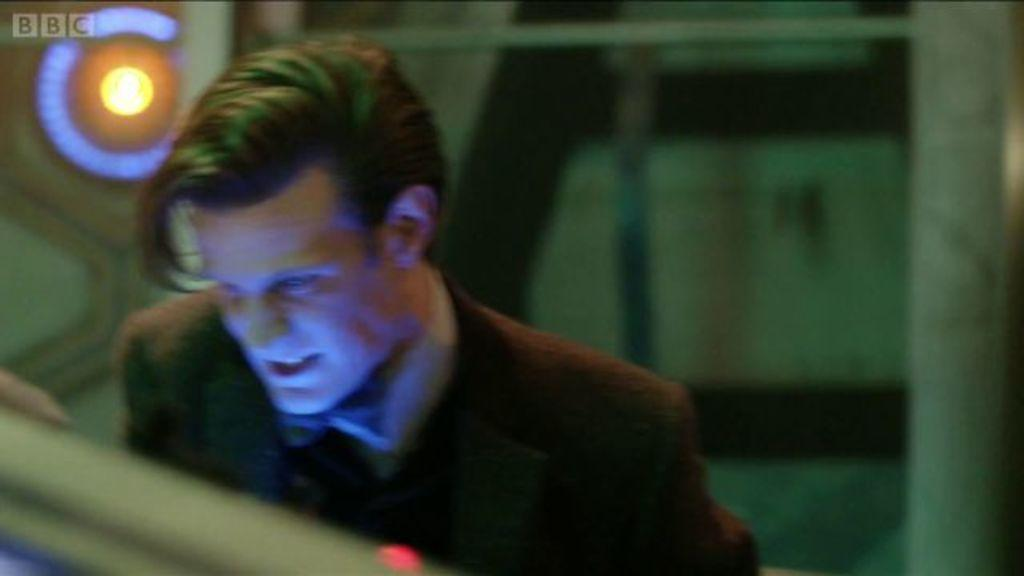What is the main subject of the image? The main subject of the image is a man standing. What is the man wearing in the image? The man is wearing a suit in the image. What can be seen in the background of the image? There is a light visible in the background of the image. What type of shoe is the man wearing in the image? The provided facts do not mention any shoes, so it cannot be determined what type of shoe the man is wearing. Is the man cooking in the image? There is no indication in the image that the man is cooking, as the facts only mention that he is wearing a suit and standing. 